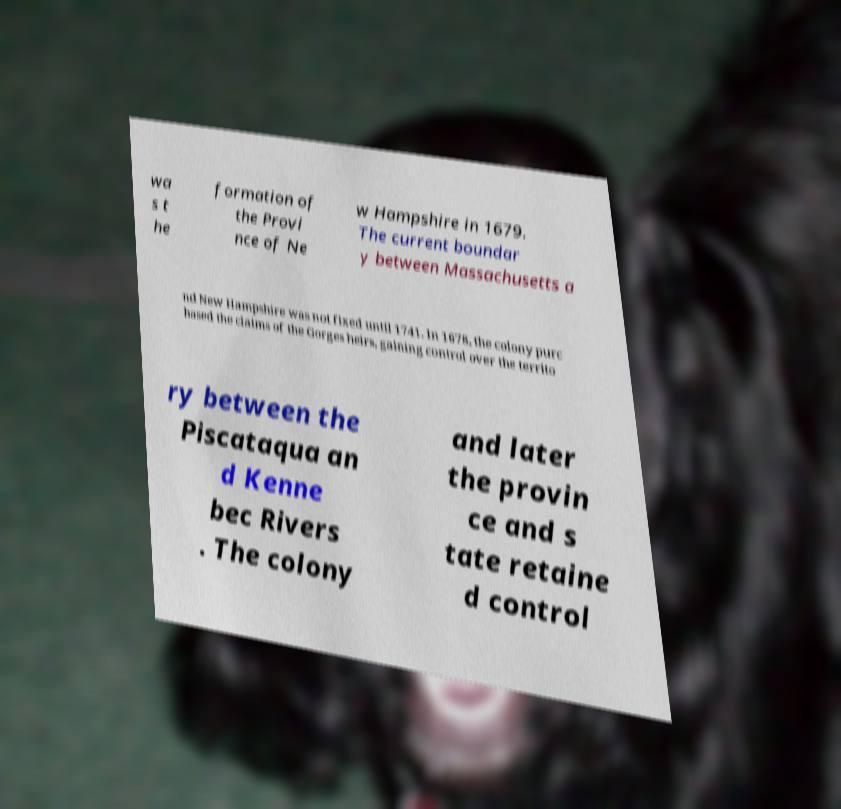Please identify and transcribe the text found in this image. wa s t he formation of the Provi nce of Ne w Hampshire in 1679. The current boundar y between Massachusetts a nd New Hampshire was not fixed until 1741. In 1678, the colony purc hased the claims of the Gorges heirs, gaining control over the territo ry between the Piscataqua an d Kenne bec Rivers . The colony and later the provin ce and s tate retaine d control 